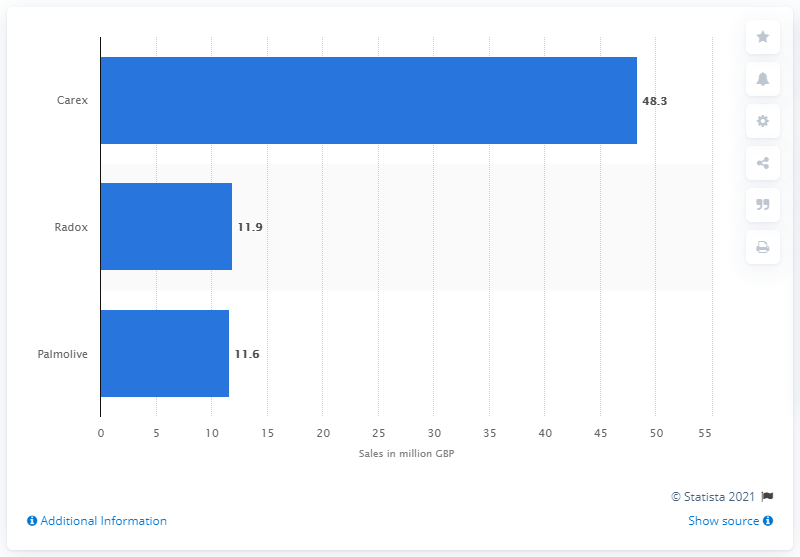Highlight a few significant elements in this photo. The Carex brand of liquid soap was the highest selling liquid soap brand in the UK in 2014. Carex generated £48.3 million in sales. 